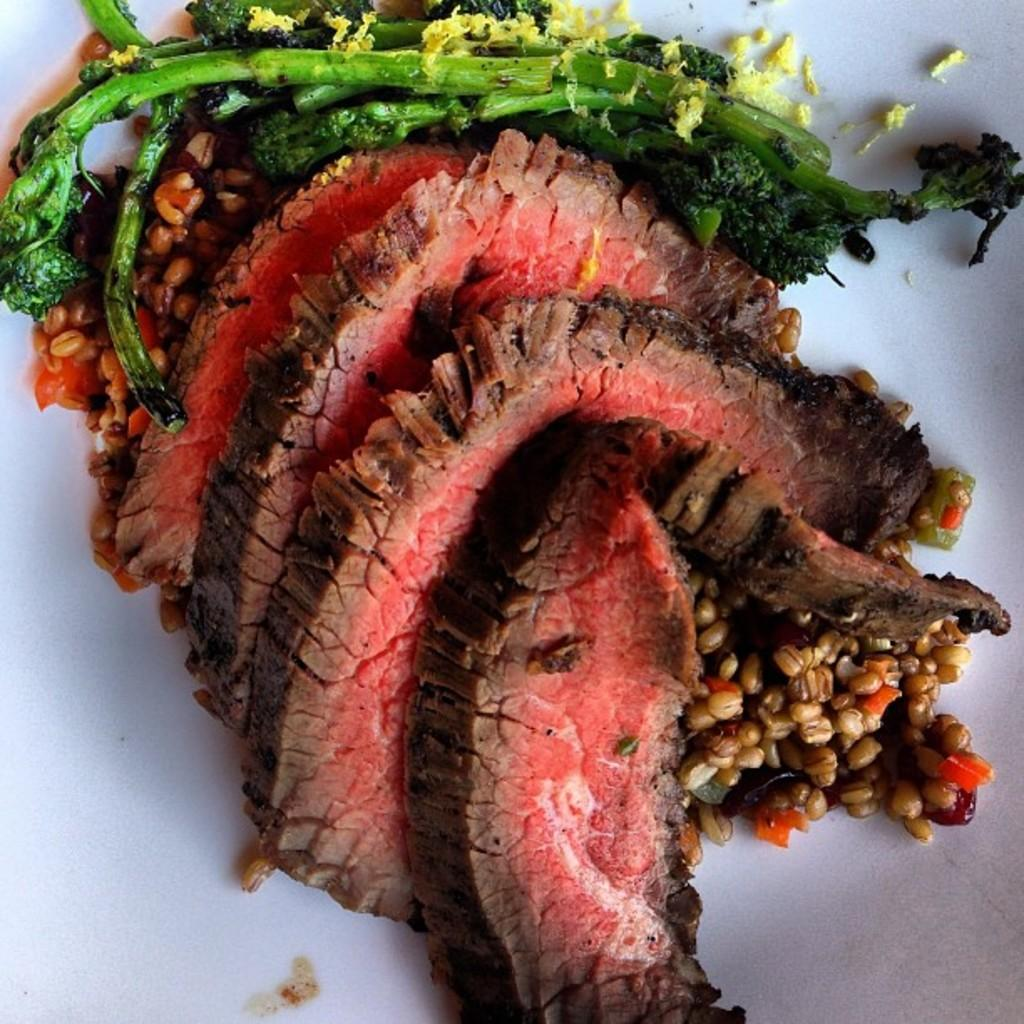What is the main subject of the image? The main subject of the image is food. What is the color of the surface on which the food is placed? The food is on a white surface. What colors can be seen in the food? The food has colors including green, yellow, red, and brown. How many hooks are attached to the volleyball in the image? There is no volleyball present in the image, so it is not possible to determine the number of hooks attached to it. 